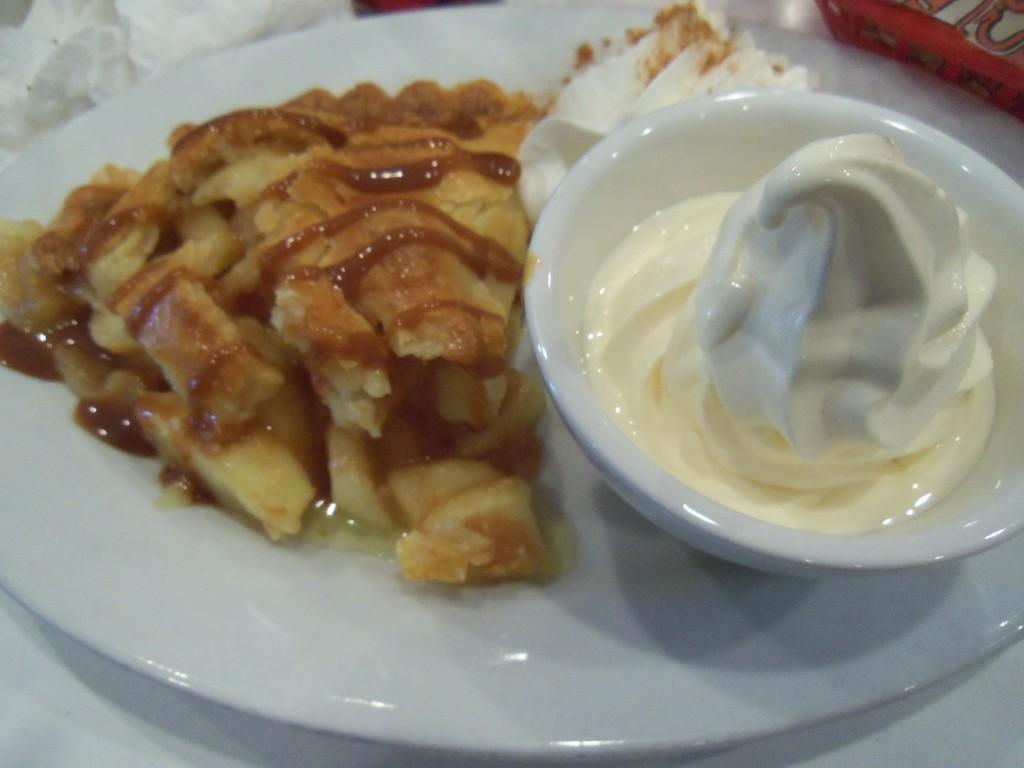What is on the table in the image? There is a white plate, a cup, a paper, and a red box on the table. What is on the white plate? There is sauce, ice cream, and a food item on the plate. Is there any ice cream in a separate container? Yes, there is a bowl with ice cream in it. Where is the library located in the image? There is no library present in the image. Is your sister in the image? The provided facts do not mention a sister, so it cannot be determined if she is in the image. 